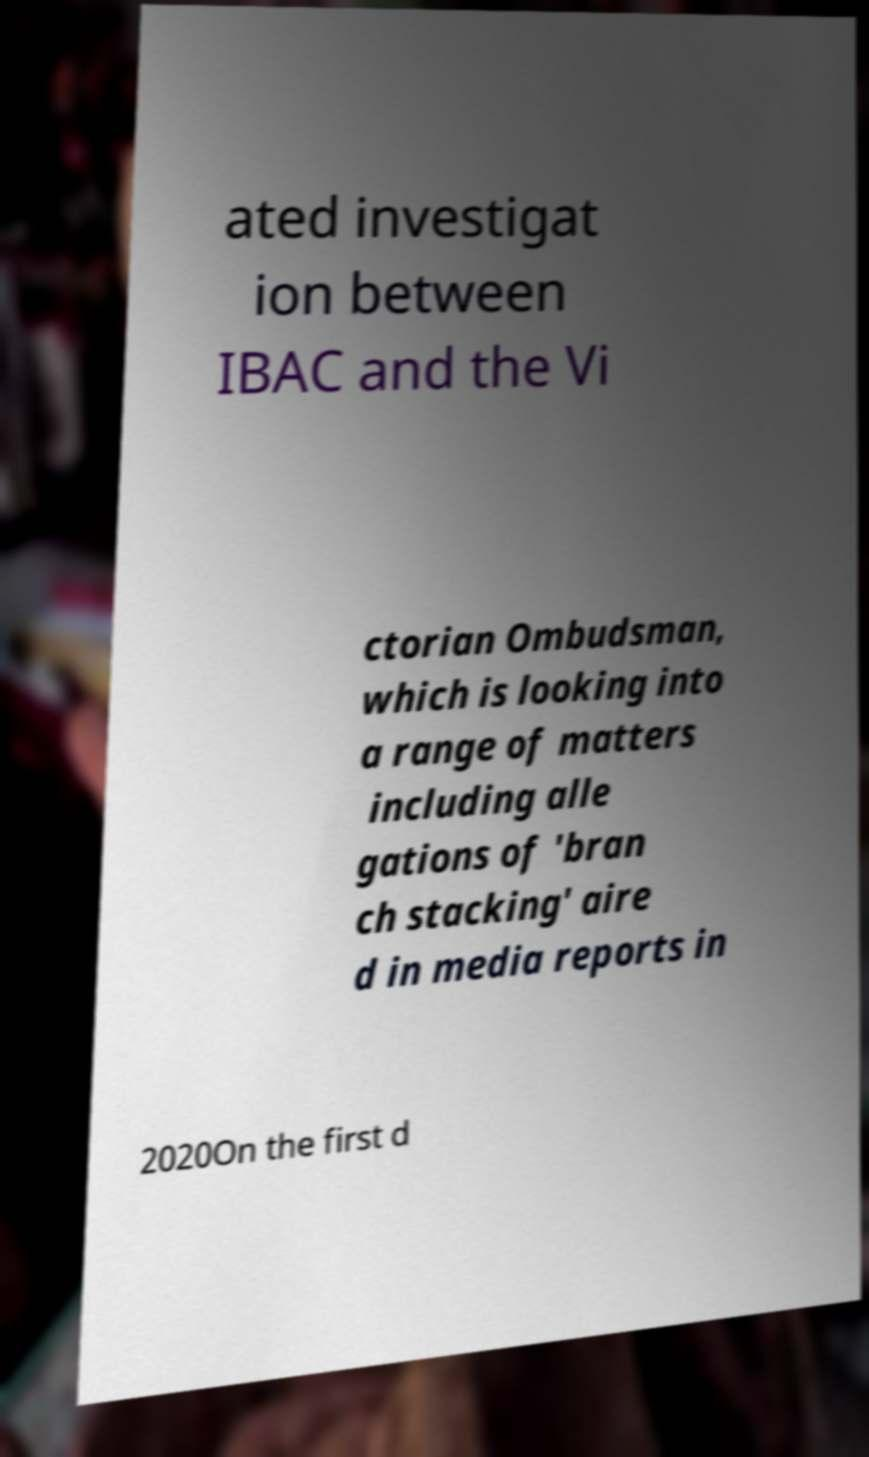What messages or text are displayed in this image? I need them in a readable, typed format. ated investigat ion between IBAC and the Vi ctorian Ombudsman, which is looking into a range of matters including alle gations of 'bran ch stacking' aire d in media reports in 2020On the first d 